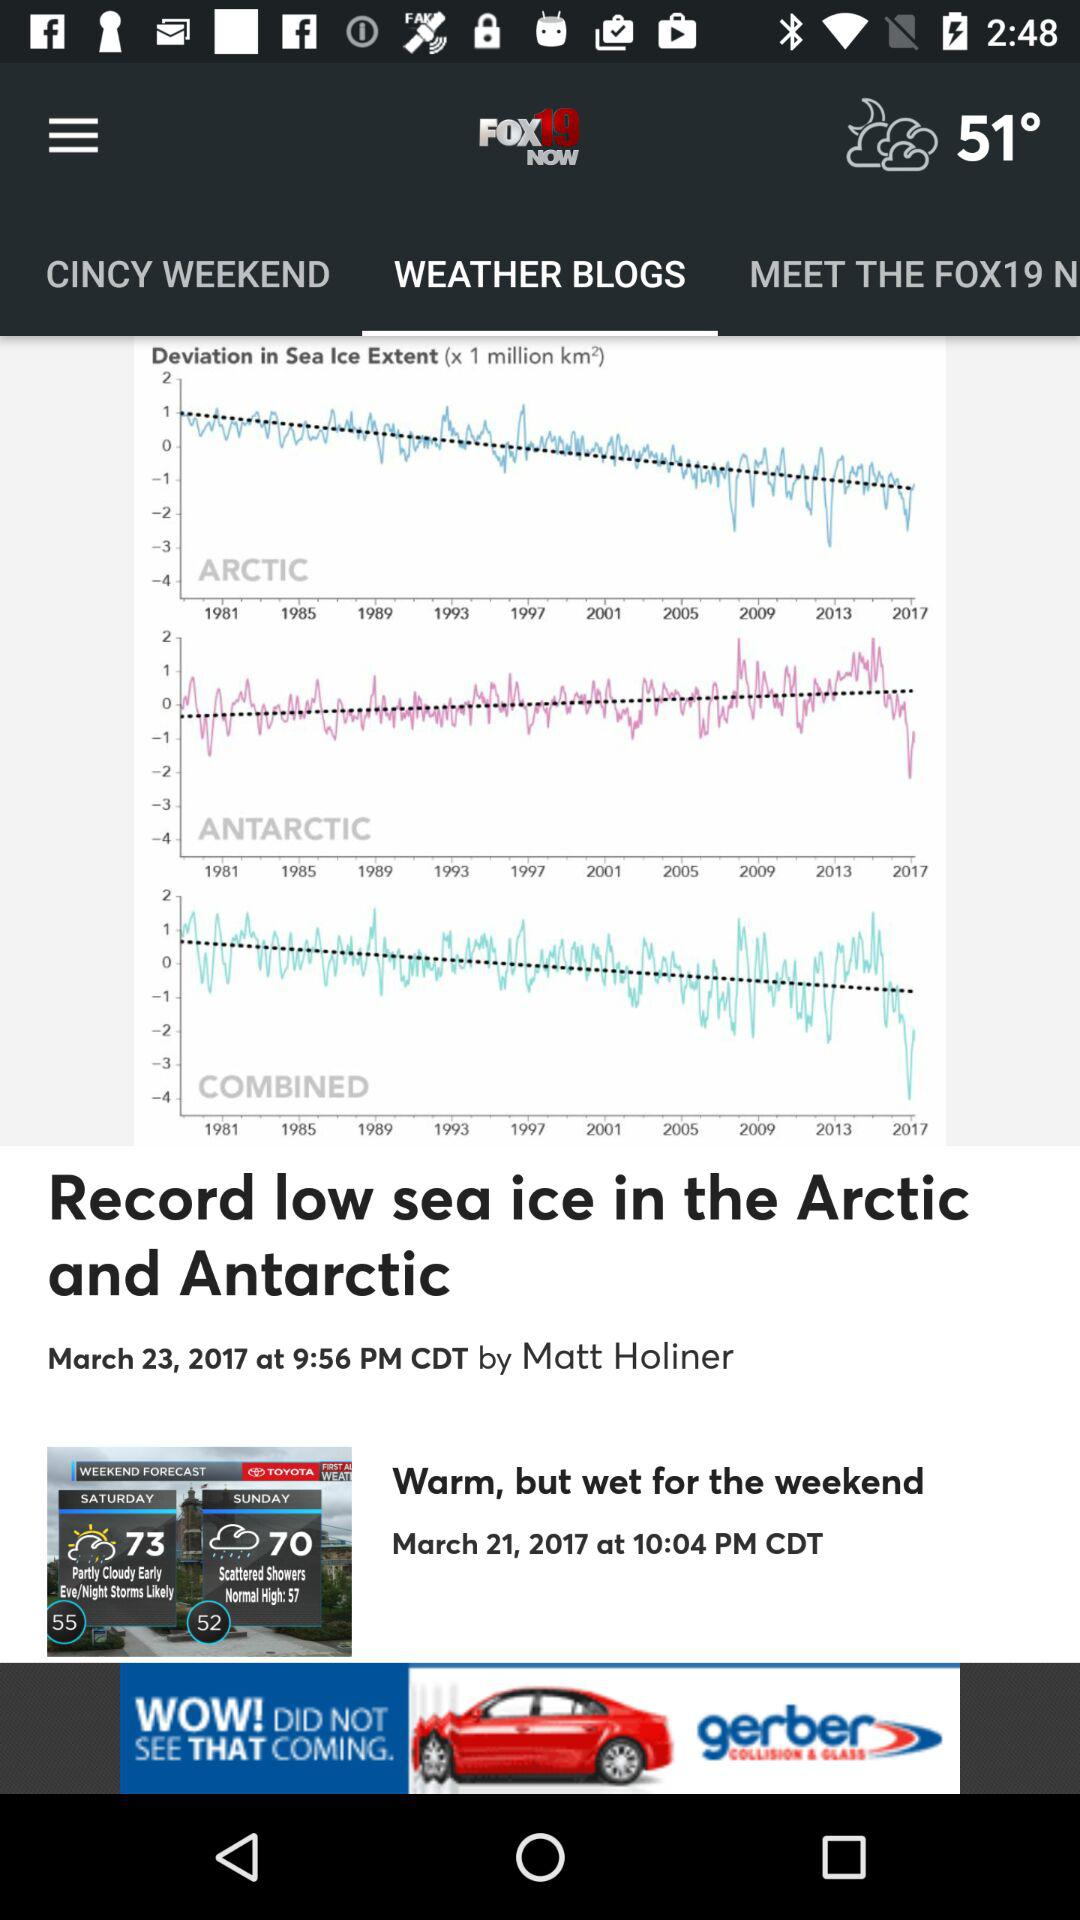What is the temperature? It appears the image shows a website with weather information and articles, but the specific temperature cannot be discerned from this image. It’s always beneficial to refer to a reliable and current source, such as a weather service or news site, for up-to-date temperature information. 